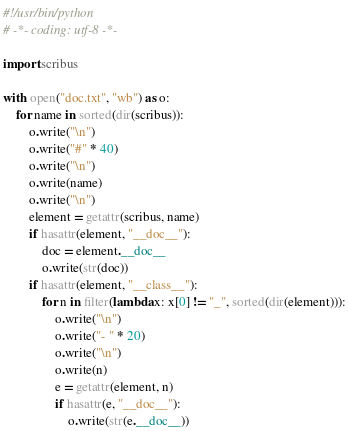Convert code to text. <code><loc_0><loc_0><loc_500><loc_500><_Python_>#!/usr/bin/python
# -*- coding: utf-8 -*-

import scribus

with open("doc.txt", "wb") as o:
    for name in sorted(dir(scribus)):
        o.write("\n")
        o.write("#" * 40)
        o.write("\n")
        o.write(name)
        o.write("\n")
        element = getattr(scribus, name)
        if hasattr(element, "__doc__"):
            doc = element.__doc__
            o.write(str(doc))
        if hasattr(element, "__class__"):
            for n in filter(lambda x: x[0] != "_", sorted(dir(element))):
                o.write("\n")
                o.write("- " * 20)
                o.write("\n")
                o.write(n)
                e = getattr(element, n)
                if hasattr(e, "__doc__"):
                    o.write(str(e.__doc__))

</code> 